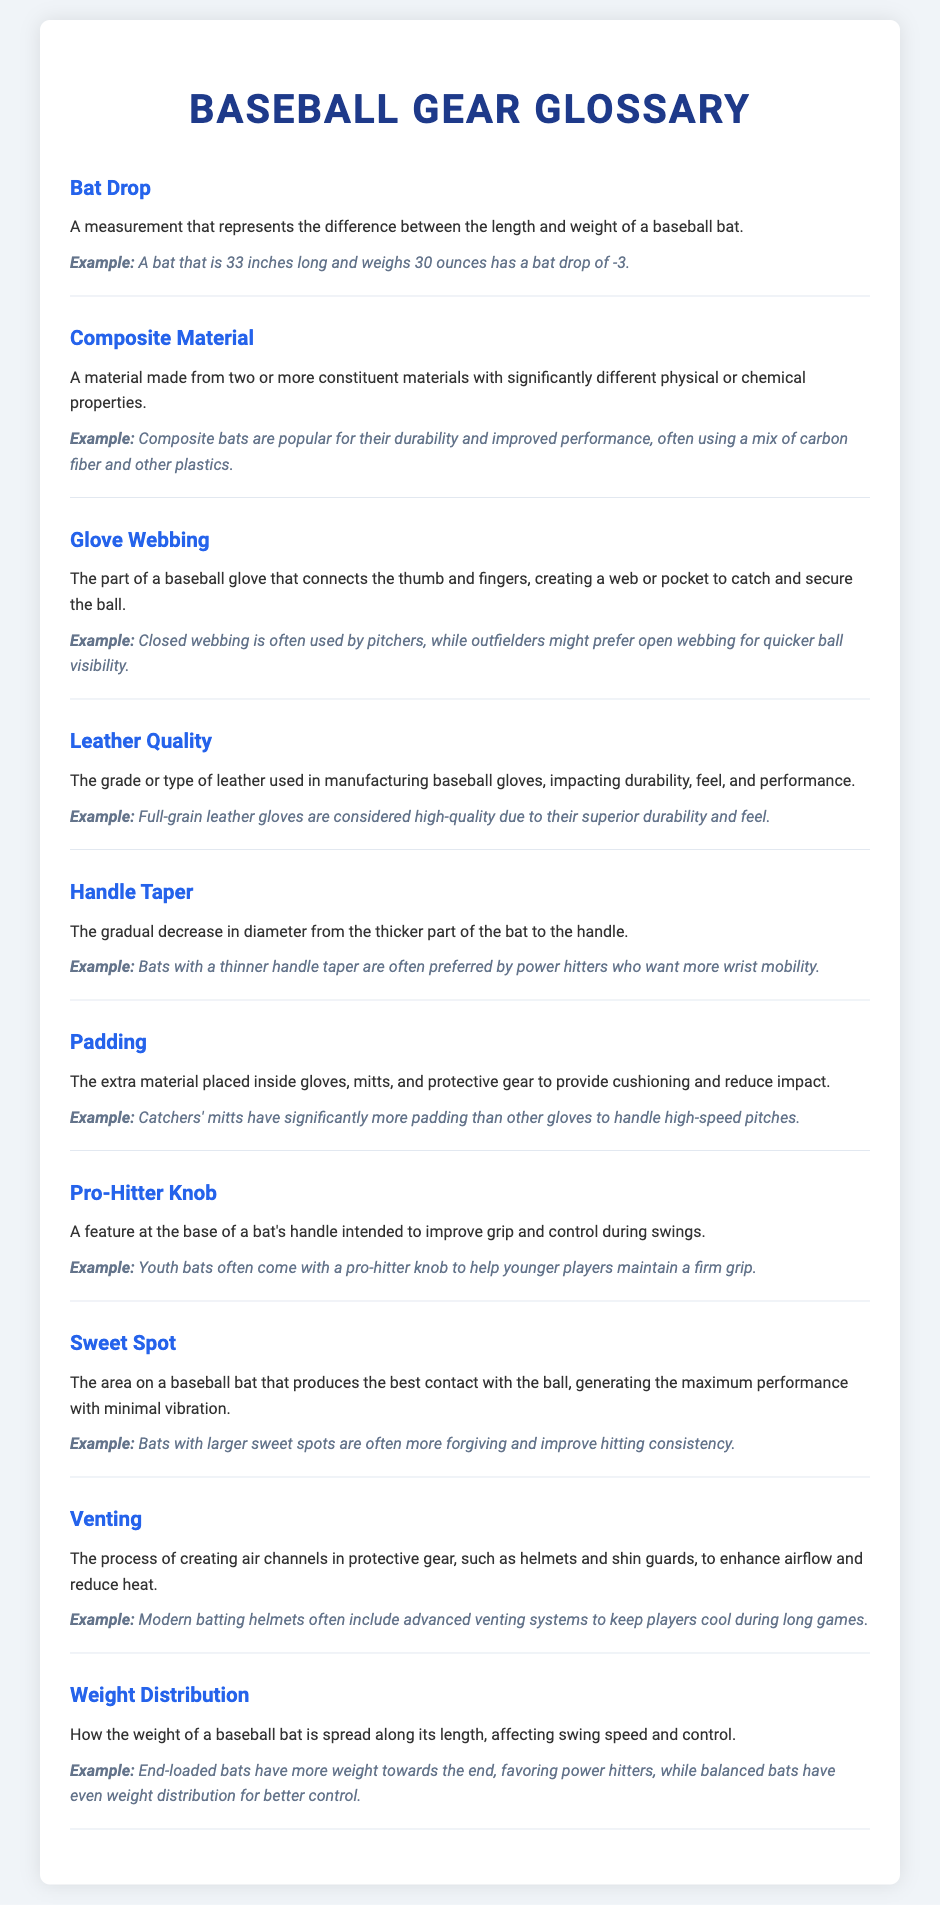What is Bat Drop? Bat Drop is a measurement that represents the difference between the length and weight of a baseball bat.
Answer: A measurement that represents the difference between the length and weight of a baseball bat What is Composite Material? Composite Material refers to a material made from two or more constituent materials with significantly different physical or chemical properties.
Answer: A material made from two or more constituent materials with significantly different physical or chemical properties What type of webbing do pitchers prefer? Pitchers often prefer closed webbing in their gloves for better control.
Answer: Closed webbing What is the example of High-Quality Leather? Full-grain leather gloves are considered high-quality due to their superior durability and feel.
Answer: Full-grain leather What does Handle Taper affect? Handle Taper affects the gradual decrease in diameter from the thicker part of the bat to the handle, influencing grip.
Answer: The gradual decrease in diameter from the thicker part of the bat to the handle What is the purpose of Venting? Venting creates air channels in protective gear to enhance airflow and reduce heat during play.
Answer: To enhance airflow and reduce heat What feature helps younger players maintain a grip? The Pro-Hitter Knob at the base of a bat's handle helps younger players maintain a firm grip.
Answer: Pro-Hitter Knob How does weight distribution differ in bats? End-loaded bats have more weight towards the end, while balanced bats have even weight distribution for better control.
Answer: End-loaded and balanced bats 